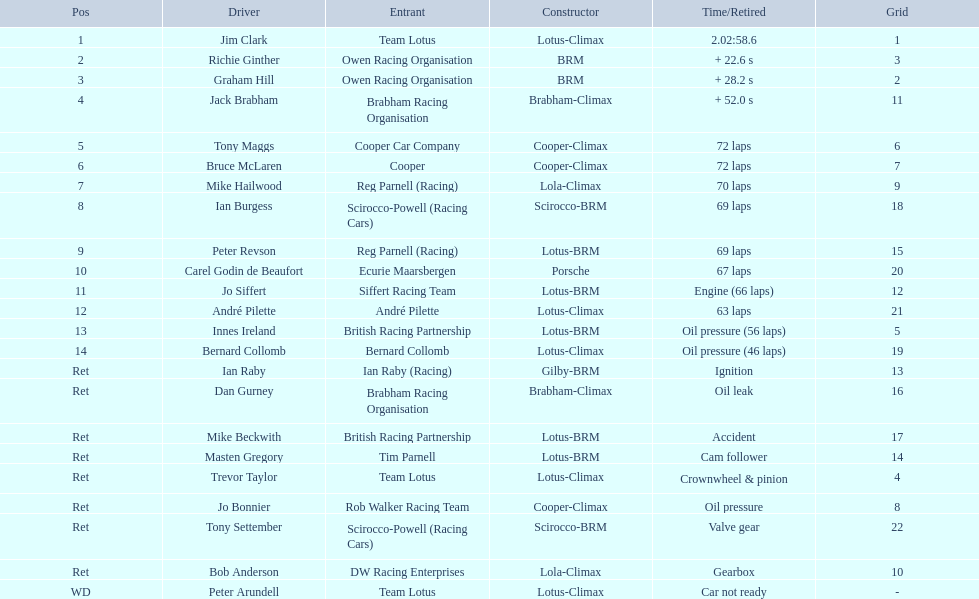Can you give me this table as a dict? {'header': ['Pos', 'Driver', 'Entrant', 'Constructor', 'Time/Retired', 'Grid'], 'rows': [['1', 'Jim Clark', 'Team Lotus', 'Lotus-Climax', '2.02:58.6', '1'], ['2', 'Richie Ginther', 'Owen Racing Organisation', 'BRM', '+ 22.6 s', '3'], ['3', 'Graham Hill', 'Owen Racing Organisation', 'BRM', '+ 28.2 s', '2'], ['4', 'Jack Brabham', 'Brabham Racing Organisation', 'Brabham-Climax', '+ 52.0 s', '11'], ['5', 'Tony Maggs', 'Cooper Car Company', 'Cooper-Climax', '72 laps', '6'], ['6', 'Bruce McLaren', 'Cooper', 'Cooper-Climax', '72 laps', '7'], ['7', 'Mike Hailwood', 'Reg Parnell (Racing)', 'Lola-Climax', '70 laps', '9'], ['8', 'Ian Burgess', 'Scirocco-Powell (Racing Cars)', 'Scirocco-BRM', '69 laps', '18'], ['9', 'Peter Revson', 'Reg Parnell (Racing)', 'Lotus-BRM', '69 laps', '15'], ['10', 'Carel Godin de Beaufort', 'Ecurie Maarsbergen', 'Porsche', '67 laps', '20'], ['11', 'Jo Siffert', 'Siffert Racing Team', 'Lotus-BRM', 'Engine (66 laps)', '12'], ['12', 'André Pilette', 'André Pilette', 'Lotus-Climax', '63 laps', '21'], ['13', 'Innes Ireland', 'British Racing Partnership', 'Lotus-BRM', 'Oil pressure (56 laps)', '5'], ['14', 'Bernard Collomb', 'Bernard Collomb', 'Lotus-Climax', 'Oil pressure (46 laps)', '19'], ['Ret', 'Ian Raby', 'Ian Raby (Racing)', 'Gilby-BRM', 'Ignition', '13'], ['Ret', 'Dan Gurney', 'Brabham Racing Organisation', 'Brabham-Climax', 'Oil leak', '16'], ['Ret', 'Mike Beckwith', 'British Racing Partnership', 'Lotus-BRM', 'Accident', '17'], ['Ret', 'Masten Gregory', 'Tim Parnell', 'Lotus-BRM', 'Cam follower', '14'], ['Ret', 'Trevor Taylor', 'Team Lotus', 'Lotus-Climax', 'Crownwheel & pinion', '4'], ['Ret', 'Jo Bonnier', 'Rob Walker Racing Team', 'Cooper-Climax', 'Oil pressure', '8'], ['Ret', 'Tony Settember', 'Scirocco-Powell (Racing Cars)', 'Scirocco-BRM', 'Valve gear', '22'], ['Ret', 'Bob Anderson', 'DW Racing Enterprises', 'Lola-Climax', 'Gearbox', '10'], ['WD', 'Peter Arundell', 'Team Lotus', 'Lotus-Climax', 'Car not ready', '-']]} Who were the two individuals who encountered a similar issue? Innes Ireland. What was the issue they both faced? Oil pressure. 